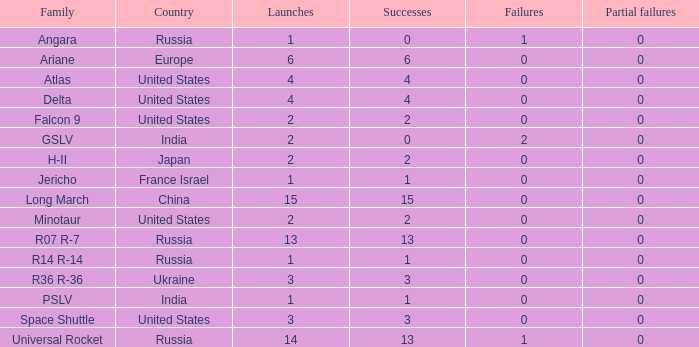Write the full table. {'header': ['Family', 'Country', 'Launches', 'Successes', 'Failures', 'Partial failures'], 'rows': [['Angara', 'Russia', '1', '0', '1', '0'], ['Ariane', 'Europe', '6', '6', '0', '0'], ['Atlas', 'United States', '4', '4', '0', '0'], ['Delta', 'United States', '4', '4', '0', '0'], ['Falcon 9', 'United States', '2', '2', '0', '0'], ['GSLV', 'India', '2', '0', '2', '0'], ['H-II', 'Japan', '2', '2', '0', '0'], ['Jericho', 'France Israel', '1', '1', '0', '0'], ['Long March', 'China', '15', '15', '0', '0'], ['Minotaur', 'United States', '2', '2', '0', '0'], ['R07 R-7', 'Russia', '13', '13', '0', '0'], ['R14 R-14', 'Russia', '1', '1', '0', '0'], ['R36 R-36', 'Ukraine', '3', '3', '0', '0'], ['PSLV', 'India', '1', '1', '0', '0'], ['Space Shuttle', 'United States', '3', '3', '0', '0'], ['Universal Rocket', 'Russia', '14', '13', '1', '0']]} What constitutes a partial failure in russia, with a failure greater than 0, an angara family, and more than one launch? None. 